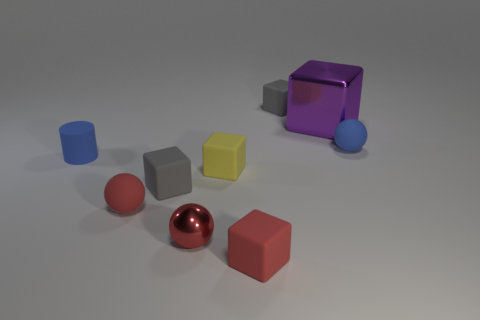Subtract all red matte balls. How many balls are left? 2 Subtract all red balls. How many balls are left? 1 Subtract all blocks. How many objects are left? 4 Subtract 2 cubes. How many cubes are left? 3 Subtract all brown cubes. Subtract all cyan balls. How many cubes are left? 5 Subtract all green balls. How many brown cylinders are left? 0 Subtract all gray metallic balls. Subtract all tiny things. How many objects are left? 1 Add 5 blocks. How many blocks are left? 10 Add 5 small yellow cylinders. How many small yellow cylinders exist? 5 Subtract 0 brown blocks. How many objects are left? 9 